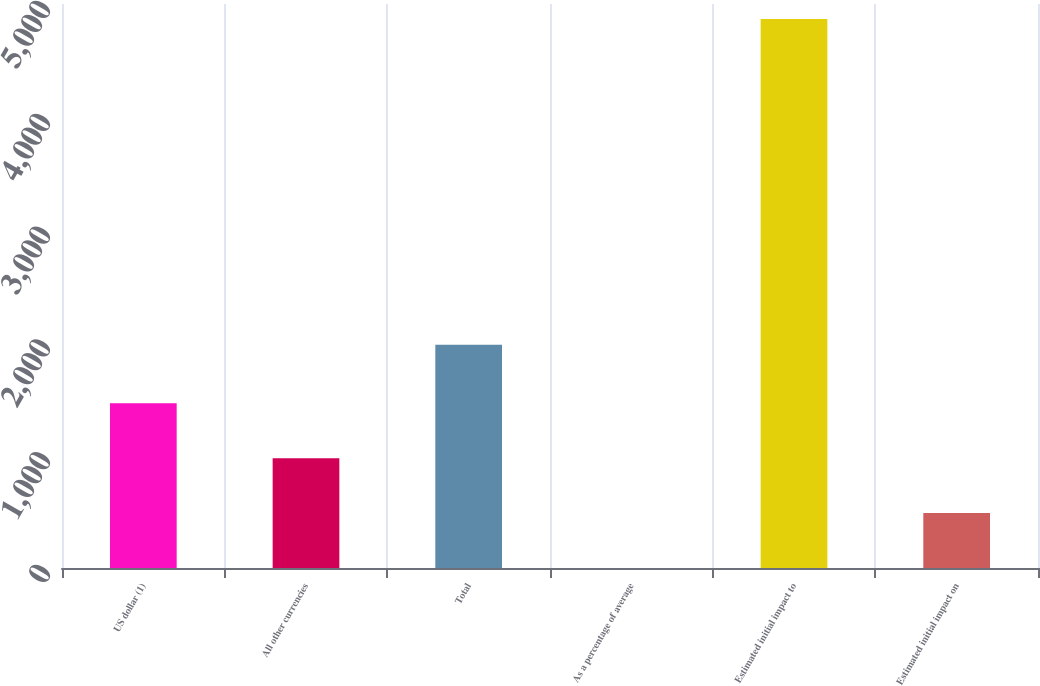<chart> <loc_0><loc_0><loc_500><loc_500><bar_chart><fcel>US dollar (1)<fcel>All other currencies<fcel>Total<fcel>As a percentage of average<fcel>Estimated initial impact to<fcel>Estimated initial impact on<nl><fcel>1460.49<fcel>973.7<fcel>1979<fcel>0.12<fcel>4868<fcel>486.91<nl></chart> 